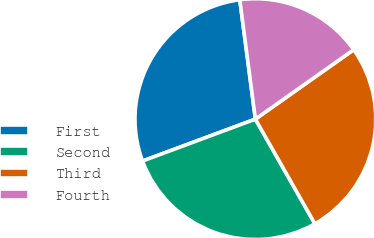<chart> <loc_0><loc_0><loc_500><loc_500><pie_chart><fcel>First<fcel>Second<fcel>Third<fcel>Fourth<nl><fcel>28.59%<fcel>27.57%<fcel>26.56%<fcel>17.28%<nl></chart> 